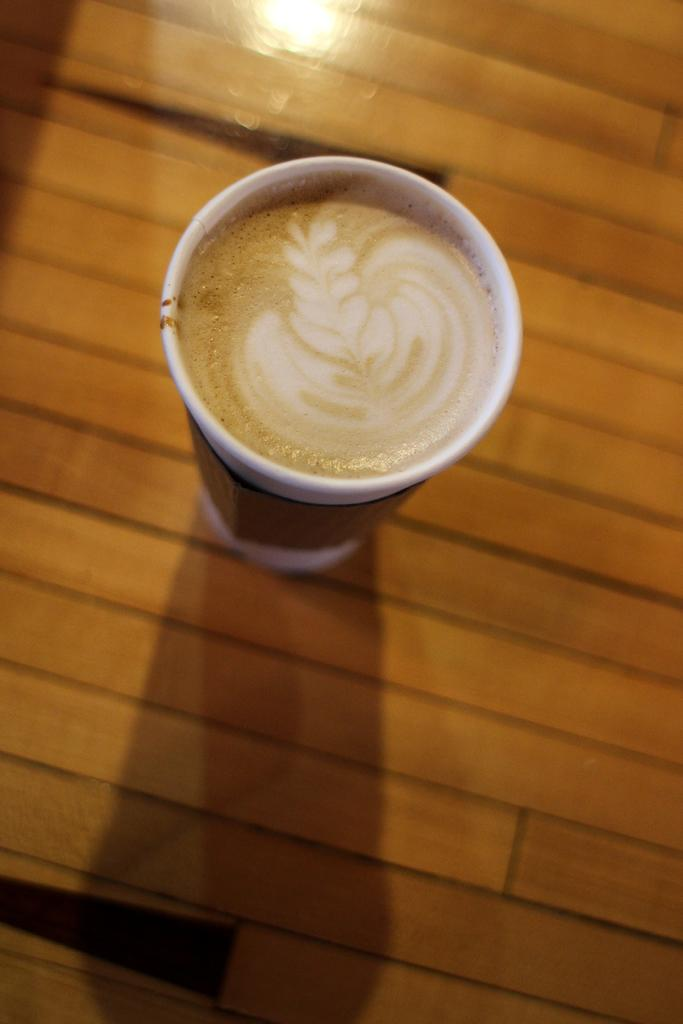What is present on the table in the image? There is a coffee cup on the table in the image. Can you describe the location of the coffee cup in the image? The coffee cup is on a table in the image. What type of glue can be seen on the coffee cup in the image? There is no glue present on the coffee cup in the image. What sound does the coffee cup make in the image? The image is a still picture, so there is no sound associated with the coffee cup. 